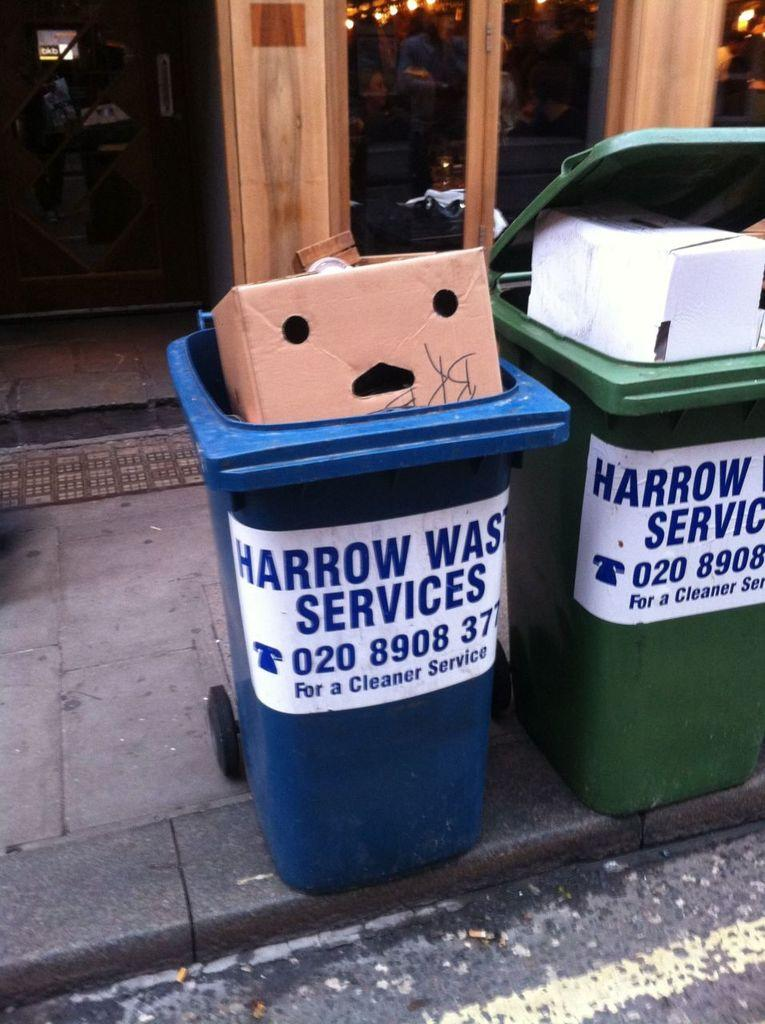Provide a one-sentence caption for the provided image. Harrow Waste Services has bins for trash and recycling at the curb. 